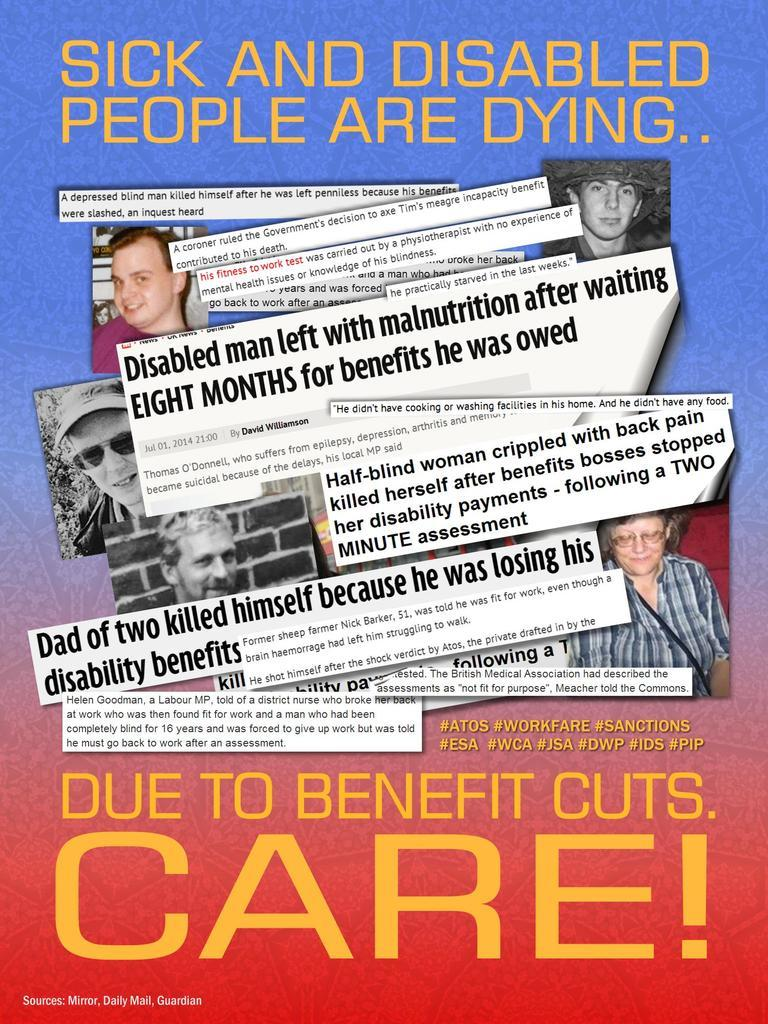<image>
Present a compact description of the photo's key features. An ad that says "Sick and Disabled People re Dying..." 